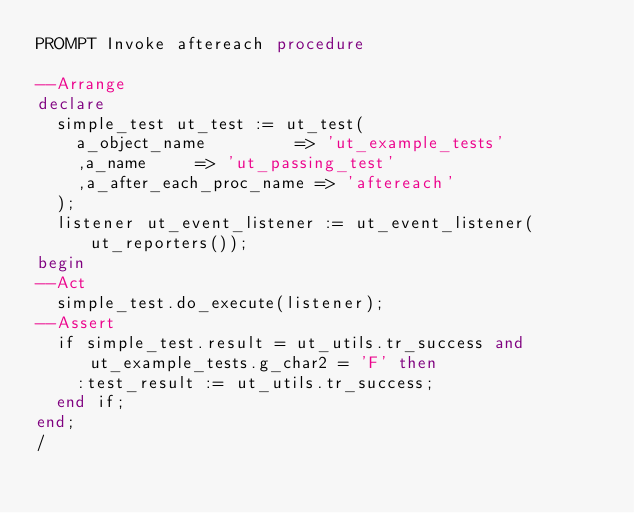<code> <loc_0><loc_0><loc_500><loc_500><_SQL_>PROMPT Invoke aftereach procedure

--Arrange
declare
  simple_test ut_test := ut_test(
    a_object_name         => 'ut_example_tests'
    ,a_name     => 'ut_passing_test'
    ,a_after_each_proc_name => 'aftereach'
  );
  listener ut_event_listener := ut_event_listener(ut_reporters());
begin
--Act
  simple_test.do_execute(listener);
--Assert
  if simple_test.result = ut_utils.tr_success and ut_example_tests.g_char2 = 'F' then
    :test_result := ut_utils.tr_success;
  end if;
end;
/

</code> 